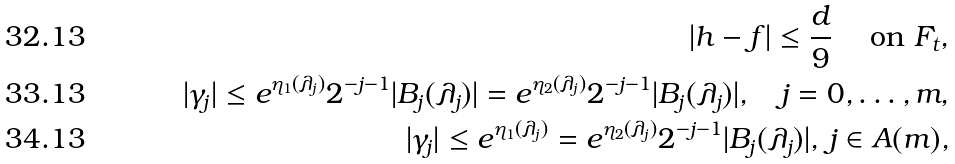Convert formula to latex. <formula><loc_0><loc_0><loc_500><loc_500>| h - f | \leq \frac { d } { 9 } \quad \text { on } F _ { t } , \\ | \gamma _ { j } | \leq e ^ { \eta _ { 1 } ( \lambda _ { j } ) } 2 ^ { - j - 1 } | B _ { j } ( \lambda _ { j } ) | = e ^ { \eta _ { 2 } ( \lambda _ { j } ) } 2 ^ { - j - 1 } | B _ { j } ( \lambda _ { j } ) | , \quad j = 0 , \dots , m , \\ | \gamma _ { j } | \leq e ^ { \eta _ { 1 } ( \lambda _ { j } ) } = e ^ { \eta _ { 2 } ( \lambda _ { j } ) } 2 ^ { - j - 1 } | B _ { j } ( \lambda _ { j } ) | , \, j \in A ( m ) ,</formula> 